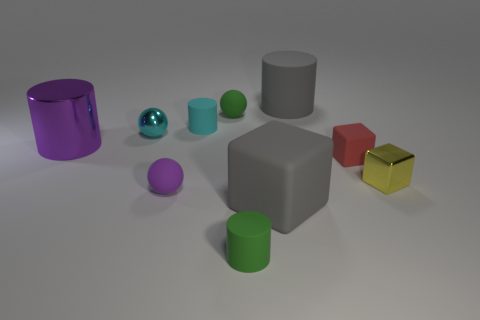What is the size of the object that is both behind the metal cylinder and left of the purple ball?
Ensure brevity in your answer.  Small. Are there more large red balls than tiny cyan shiny objects?
Keep it short and to the point. No. Are there any tiny matte things of the same color as the big metallic cylinder?
Give a very brief answer. Yes. Does the matte ball that is behind the purple sphere have the same size as the shiny cylinder?
Your answer should be compact. No. Is the number of gray matte things less than the number of big purple shiny things?
Give a very brief answer. No. Is there a tiny green thing that has the same material as the small yellow thing?
Your answer should be compact. No. The thing that is to the right of the red thing has what shape?
Give a very brief answer. Cube. Is the color of the small cylinder behind the metal cube the same as the metal ball?
Give a very brief answer. Yes. Are there fewer big metallic cylinders that are on the left side of the tiny red block than cubes?
Offer a very short reply. Yes. There is a tiny block that is made of the same material as the green cylinder; what is its color?
Give a very brief answer. Red. 